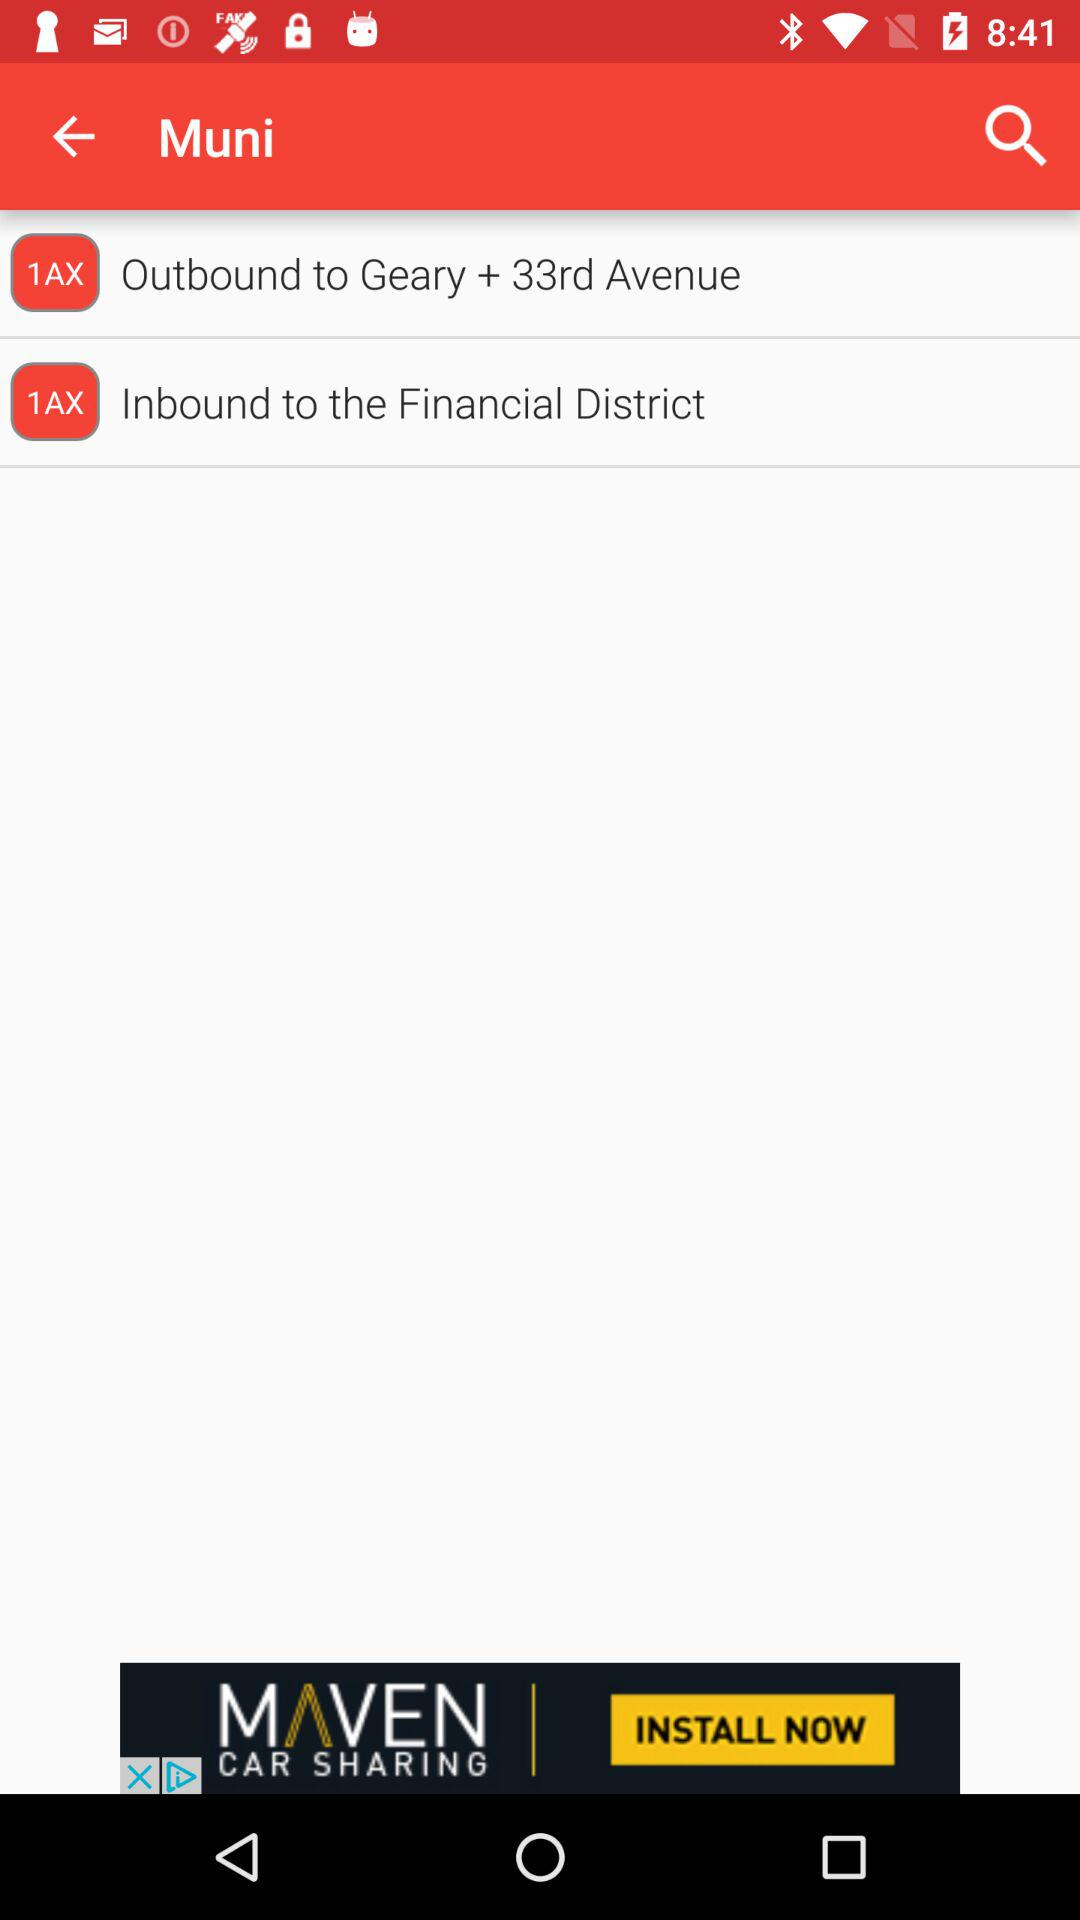How many 1AX routes are displayed?
Answer the question using a single word or phrase. 2 